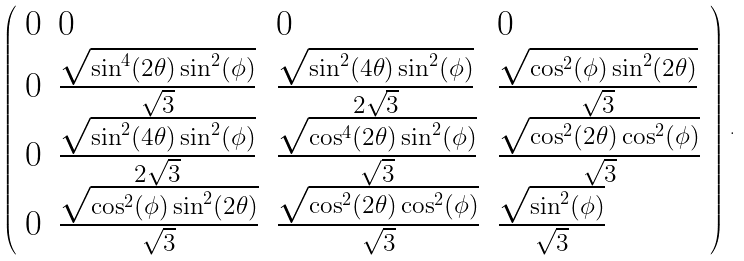<formula> <loc_0><loc_0><loc_500><loc_500>\left ( \begin{array} { l l l l } 0 & 0 & 0 & 0 \\ 0 & \frac { \sqrt { \sin ^ { 4 } ( 2 \theta ) \sin ^ { 2 } ( \phi ) } } { \sqrt { 3 } } & \frac { \sqrt { \sin ^ { 2 } ( 4 \theta ) \sin ^ { 2 } ( \phi ) } } { 2 \sqrt { 3 } } & \frac { \sqrt { \cos ^ { 2 } ( \phi ) \sin ^ { 2 } ( 2 \theta ) } } { \sqrt { 3 } } \\ 0 & \frac { \sqrt { \sin ^ { 2 } ( 4 \theta ) \sin ^ { 2 } ( \phi ) } } { 2 \sqrt { 3 } } & \frac { \sqrt { \cos ^ { 4 } ( 2 \theta ) \sin ^ { 2 } ( \phi ) } } { \sqrt { 3 } } & \frac { \sqrt { \cos ^ { 2 } ( 2 \theta ) \cos ^ { 2 } ( \phi ) } } { \sqrt { 3 } } \\ 0 & \frac { \sqrt { \cos ^ { 2 } ( \phi ) \sin ^ { 2 } ( 2 \theta ) } } { \sqrt { 3 } } & \frac { \sqrt { \cos ^ { 2 } ( 2 \theta ) \cos ^ { 2 } ( \phi ) } } { \sqrt { 3 } } & \frac { \sqrt { \sin ^ { 2 } ( \phi ) } } { \sqrt { 3 } } \end{array} \right ) \, .</formula> 